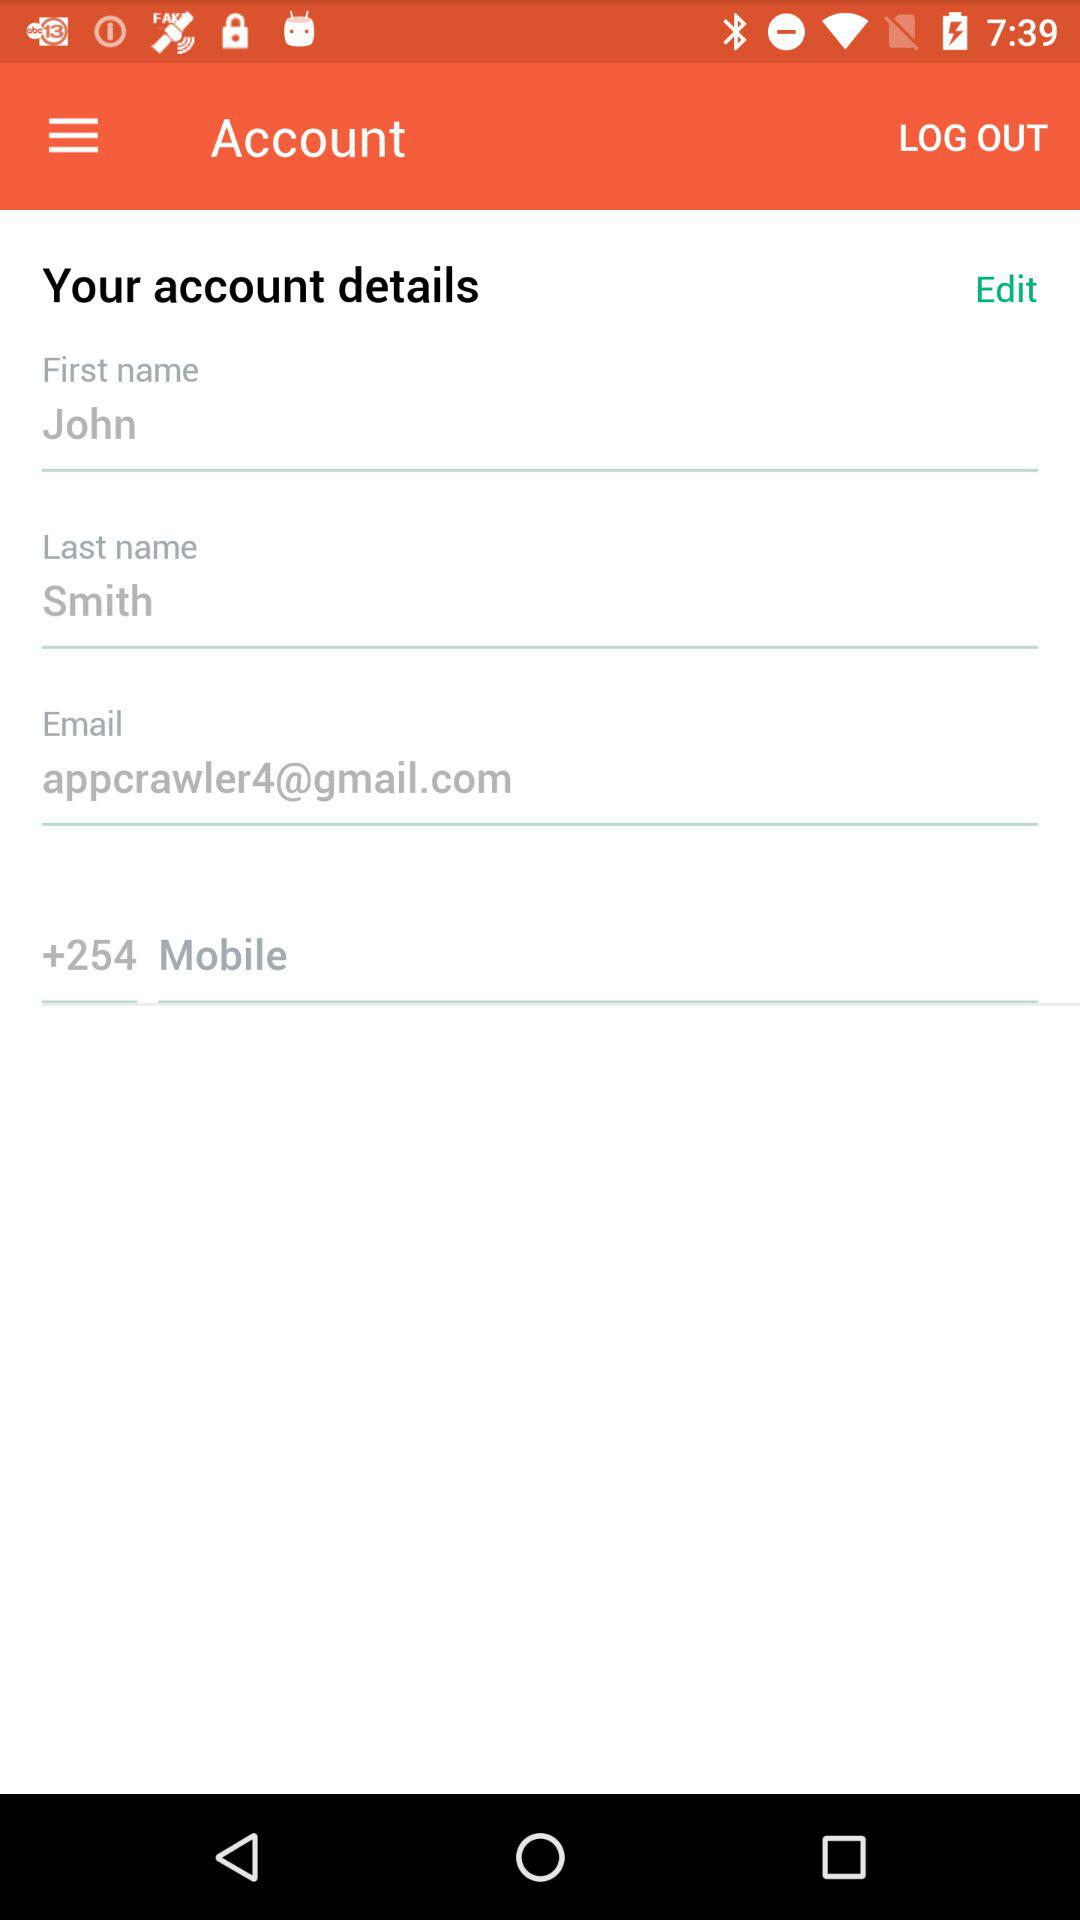What is the email address? The email address is appcrawler4@gmail.com. 